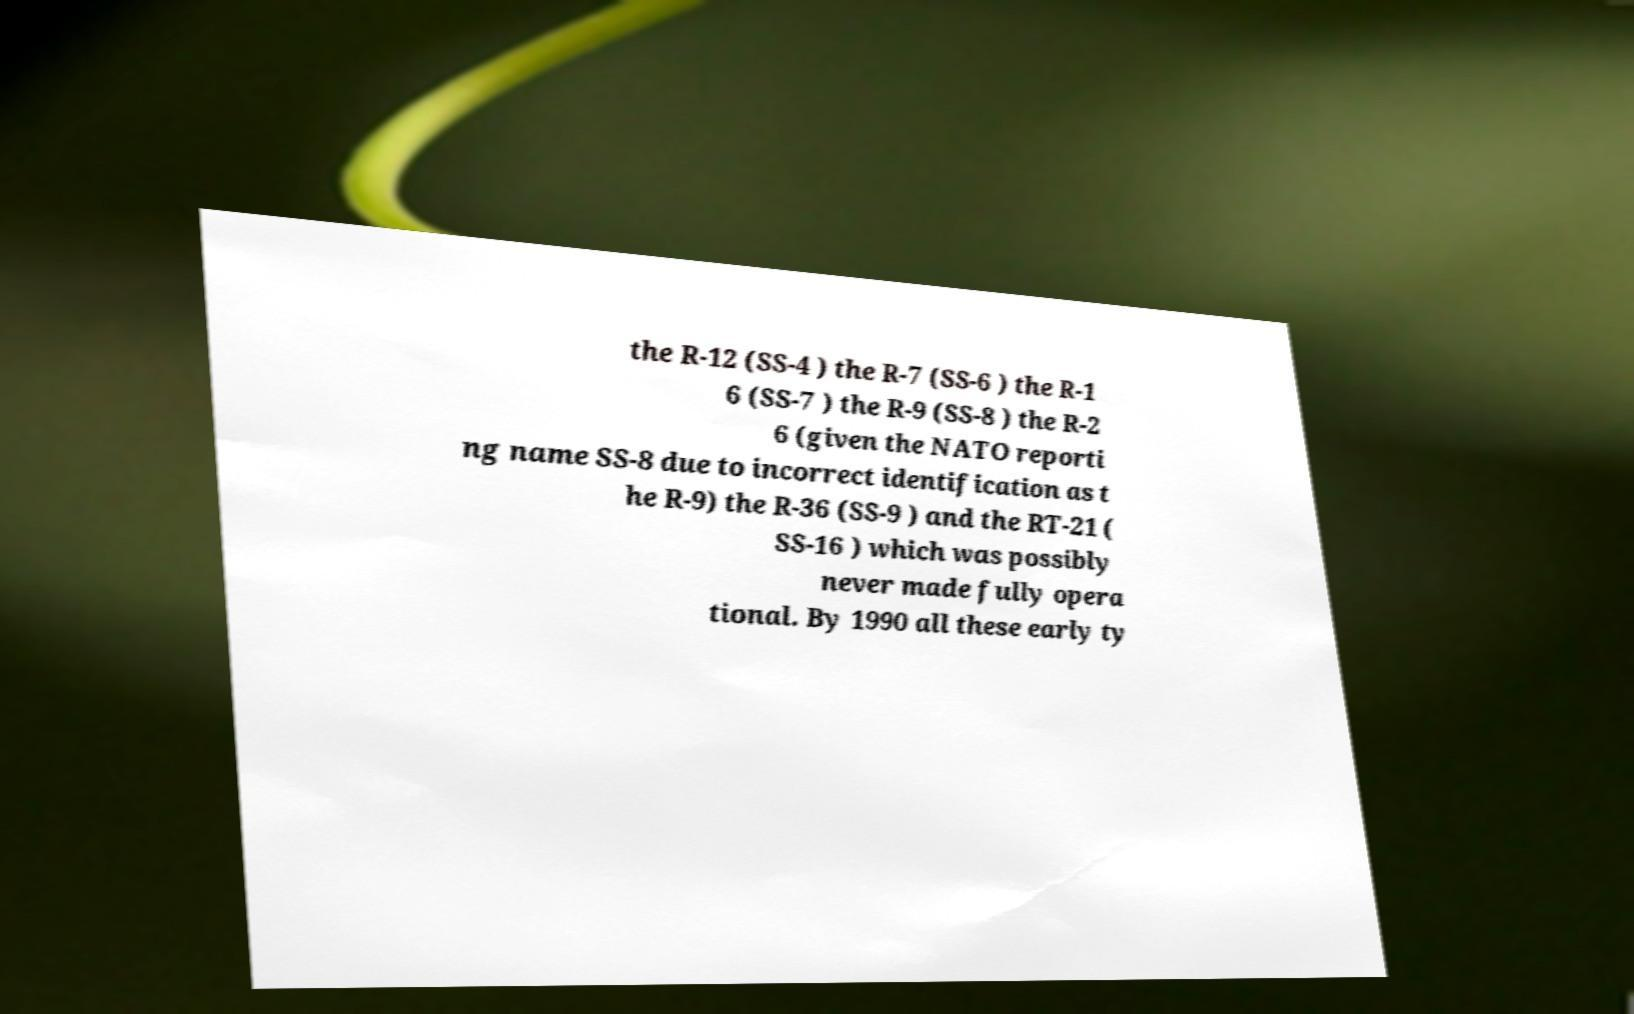Please identify and transcribe the text found in this image. the R-12 (SS-4 ) the R-7 (SS-6 ) the R-1 6 (SS-7 ) the R-9 (SS-8 ) the R-2 6 (given the NATO reporti ng name SS-8 due to incorrect identification as t he R-9) the R-36 (SS-9 ) and the RT-21 ( SS-16 ) which was possibly never made fully opera tional. By 1990 all these early ty 